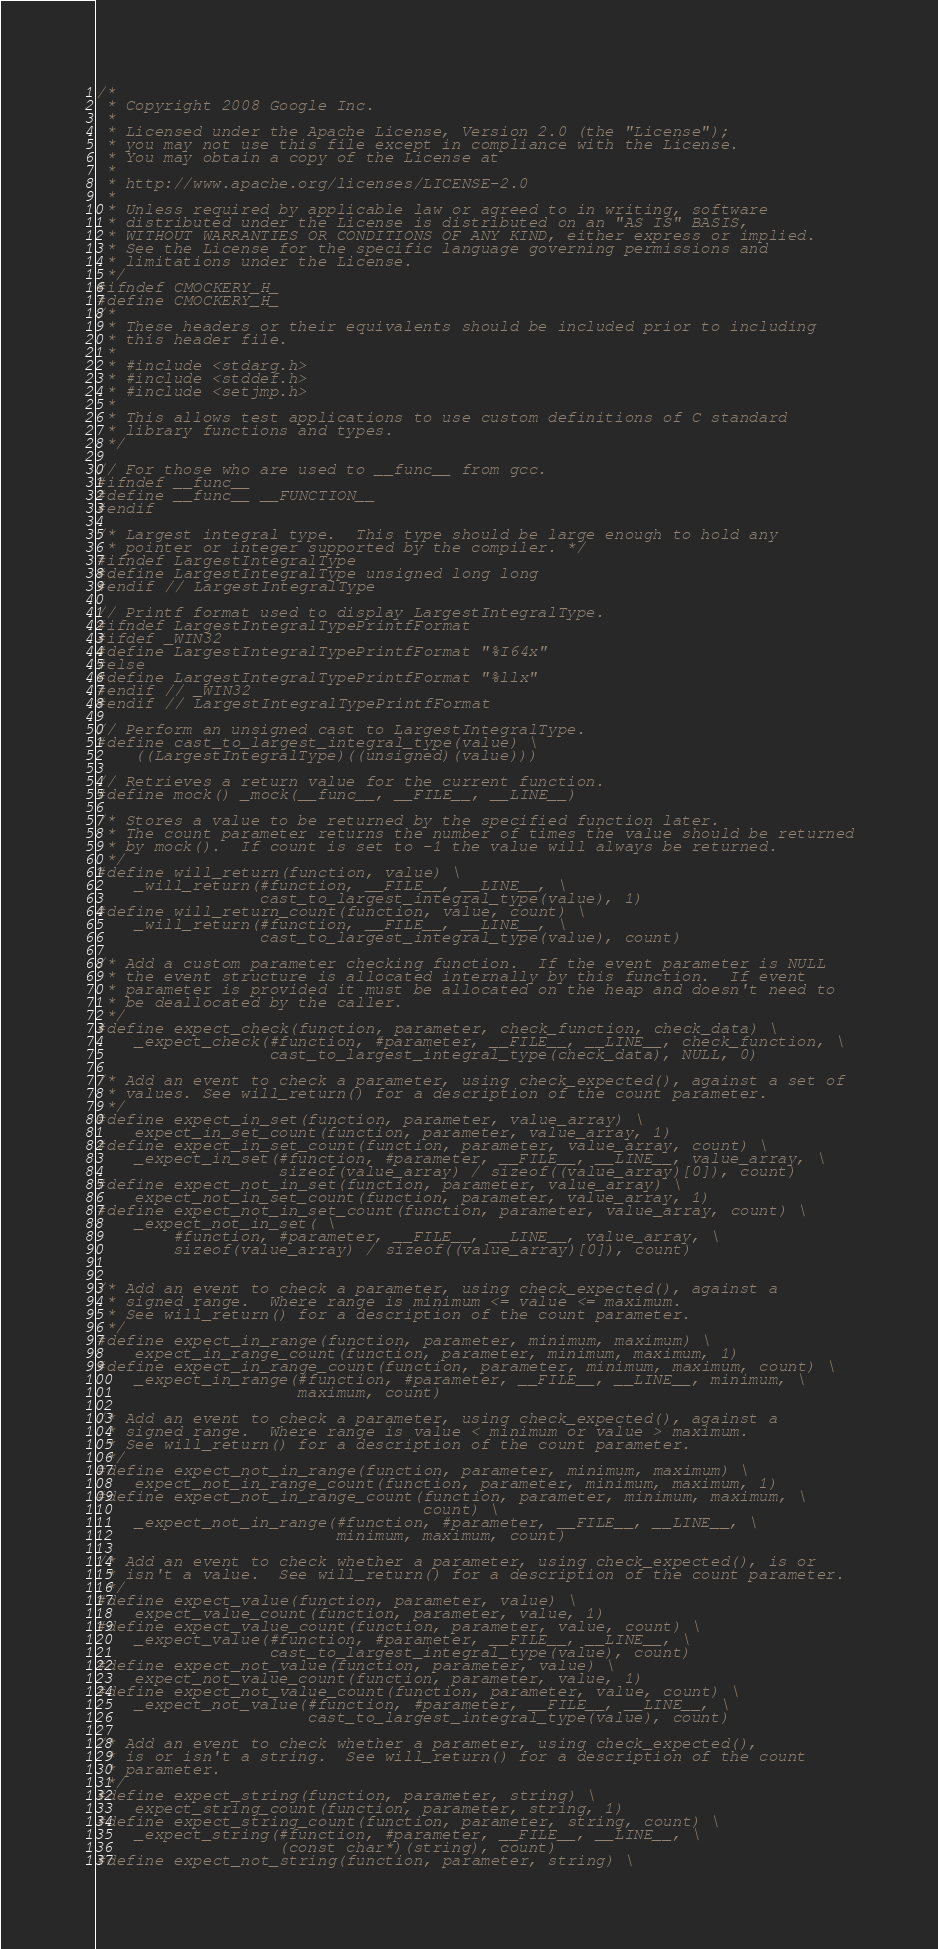Convert code to text. <code><loc_0><loc_0><loc_500><loc_500><_C_>/*
 * Copyright 2008 Google Inc.
 *
 * Licensed under the Apache License, Version 2.0 (the "License");
 * you may not use this file except in compliance with the License.
 * You may obtain a copy of the License at
 *
 * http://www.apache.org/licenses/LICENSE-2.0
 *
 * Unless required by applicable law or agreed to in writing, software
 * distributed under the License is distributed on an "AS IS" BASIS,
 * WITHOUT WARRANTIES OR CONDITIONS OF ANY KIND, either express or implied.
 * See the License for the specific language governing permissions and
 * limitations under the License.
 */
#ifndef CMOCKERY_H_
#define CMOCKERY_H_
/*
 * These headers or their equivalents should be included prior to including
 * this header file.
 *
 * #include <stdarg.h>
 * #include <stddef.h>
 * #include <setjmp.h>
 *
 * This allows test applications to use custom definitions of C standard
 * library functions and types.
 */

// For those who are used to __func__ from gcc.
#ifndef __func__
#define __func__ __FUNCTION__
#endif

/* Largest integral type.  This type should be large enough to hold any
 * pointer or integer supported by the compiler. */
#ifndef LargestIntegralType
#define LargestIntegralType unsigned long long
#endif // LargestIntegralType

// Printf format used to display LargestIntegralType.
#ifndef LargestIntegralTypePrintfFormat
#ifdef _WIN32
#define LargestIntegralTypePrintfFormat "%I64x"
#else
#define LargestIntegralTypePrintfFormat "%llx"
#endif // _WIN32
#endif // LargestIntegralTypePrintfFormat

// Perform an unsigned cast to LargestIntegralType.
#define cast_to_largest_integral_type(value) \
    ((LargestIntegralType)((unsigned)(value)))

// Retrieves a return value for the current function.
#define mock() _mock(__func__, __FILE__, __LINE__)

/* Stores a value to be returned by the specified function later.
 * The count parameter returns the number of times the value should be returned
 * by mock().  If count is set to -1 the value will always be returned.
 */
#define will_return(function, value) \
    _will_return(#function, __FILE__, __LINE__, \
                 cast_to_largest_integral_type(value), 1)
#define will_return_count(function, value, count) \
    _will_return(#function, __FILE__, __LINE__, \
                 cast_to_largest_integral_type(value), count)

/* Add a custom parameter checking function.  If the event parameter is NULL
 * the event structure is allocated internally by this function.  If event
 * parameter is provided it must be allocated on the heap and doesn't need to
 * be deallocated by the caller.
 */
#define expect_check(function, parameter, check_function, check_data) \
    _expect_check(#function, #parameter, __FILE__, __LINE__, check_function, \
                  cast_to_largest_integral_type(check_data), NULL, 0)

/* Add an event to check a parameter, using check_expected(), against a set of
 * values. See will_return() for a description of the count parameter.
 */
#define expect_in_set(function, parameter, value_array) \
    expect_in_set_count(function, parameter, value_array, 1)
#define expect_in_set_count(function, parameter, value_array, count) \
    _expect_in_set(#function, #parameter, __FILE__, __LINE__, value_array, \
                   sizeof(value_array) / sizeof((value_array)[0]), count)
#define expect_not_in_set(function, parameter, value_array) \
    expect_not_in_set_count(function, parameter, value_array, 1)
#define expect_not_in_set_count(function, parameter, value_array, count) \
    _expect_not_in_set( \
        #function, #parameter, __FILE__, __LINE__, value_array, \
        sizeof(value_array) / sizeof((value_array)[0]), count)


/* Add an event to check a parameter, using check_expected(), against a
 * signed range.  Where range is minimum <= value <= maximum.
 * See will_return() for a description of the count parameter.
 */
#define expect_in_range(function, parameter, minimum, maximum) \
    expect_in_range_count(function, parameter, minimum, maximum, 1)
#define expect_in_range_count(function, parameter, minimum, maximum, count) \
    _expect_in_range(#function, #parameter, __FILE__, __LINE__, minimum, \
                     maximum, count)

/* Add an event to check a parameter, using check_expected(), against a
 * signed range.  Where range is value < minimum or value > maximum.
 * See will_return() for a description of the count parameter.
 */
#define expect_not_in_range(function, parameter, minimum, maximum) \
    expect_not_in_range_count(function, parameter, minimum, maximum, 1)
#define expect_not_in_range_count(function, parameter, minimum, maximum, \
                                  count) \
    _expect_not_in_range(#function, #parameter, __FILE__, __LINE__, \
                         minimum, maximum, count)

/* Add an event to check whether a parameter, using check_expected(), is or
 * isn't a value.  See will_return() for a description of the count parameter.
 */
#define expect_value(function, parameter, value) \
    expect_value_count(function, parameter, value, 1)
#define expect_value_count(function, parameter, value, count) \
    _expect_value(#function, #parameter, __FILE__, __LINE__, \
                  cast_to_largest_integral_type(value), count)
#define expect_not_value(function, parameter, value) \
    expect_not_value_count(function, parameter, value, 1)
#define expect_not_value_count(function, parameter, value, count) \
    _expect_not_value(#function, #parameter, __FILE__, __LINE__, \
                      cast_to_largest_integral_type(value), count)

/* Add an event to check whether a parameter, using check_expected(),
 * is or isn't a string.  See will_return() for a description of the count
 * parameter.
 */
#define expect_string(function, parameter, string) \
    expect_string_count(function, parameter, string, 1)
#define expect_string_count(function, parameter, string, count) \
    _expect_string(#function, #parameter, __FILE__, __LINE__, \
                   (const char*)(string), count)
#define expect_not_string(function, parameter, string) \</code> 